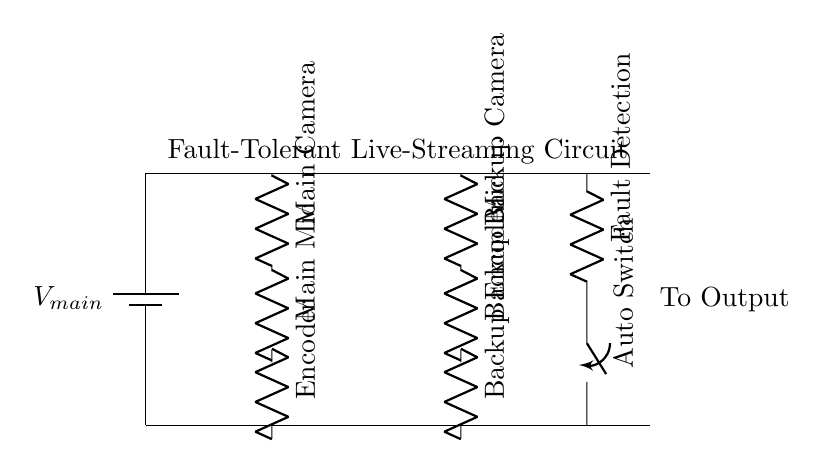What components are powered by the main supply? The main supply powers the main camera, main mic, and encoder. These components are directly connected to the main power line in the circuit, which shows they rely on this supply for operation.
Answer: Main camera, main mic, encoder What is the function of the auto switch in this circuit? The auto switch controls the connection between the main and backup equipment. If a fault is detected in the main streaming equipment, the auto switch will switch the power to the backup equipment, ensuring uninterrupted operation.
Answer: Fault switching How many branches are in the circuit? There are two branches running parallel to each other: one for the main streaming equipment and another for the backup streaming equipment. This is evidenced by the split in the circuit after the main power supply and the two paths available for current to flow.
Answer: Two What happens if a fault is detected in the main camera circuit? If a fault is detected in the main camera circuit, the auto switch will automatically switch to provide power to the backup camera, allowing the streaming operation to continue without interruption. This ensures reliability in live-streaming conditions.
Answer: It switches to backup Which component is responsible for fault detection? The fault detection component is labeled as 'Fault Detection' in the diagram. This component monitors the main equipment's performance and is crucial for activating the switch when issues arise.
Answer: Fault Detection What type of circuit is illustrated in this diagram? The diagram depicts a fault-tolerant parallel circuit, where multiple paths exist for current to flow, specifically designed to maintain operation despite faults in one branch. This allows for continued functionality of the streaming equipment.
Answer: Parallel circuit 